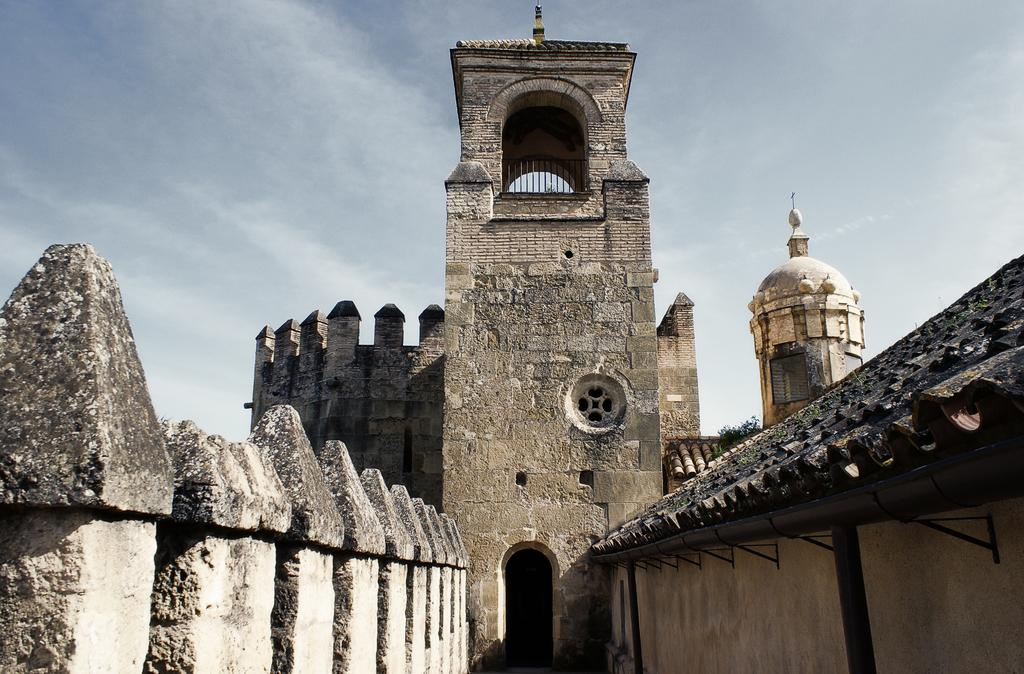What type of structure can be seen in the image? There is a fort in the image. What can be seen in the sky in the image? Clouds are visible in the image. What type of net is being used to catch the paste in the image? There is no net or paste present in the image; it features a fort and clouds. 